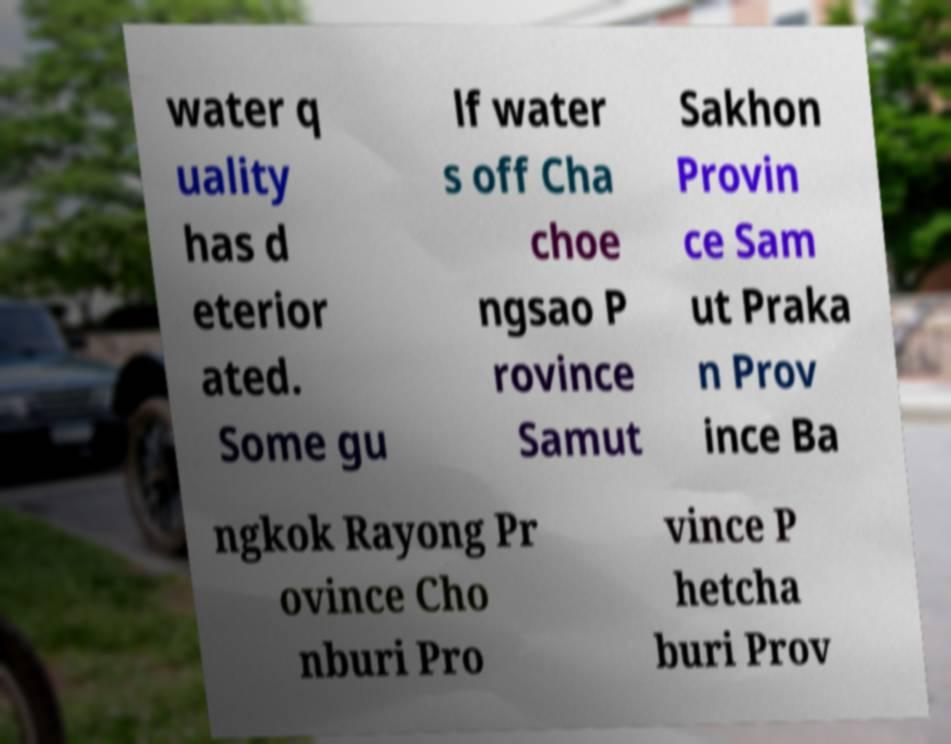Please read and relay the text visible in this image. What does it say? water q uality has d eterior ated. Some gu lf water s off Cha choe ngsao P rovince Samut Sakhon Provin ce Sam ut Praka n Prov ince Ba ngkok Rayong Pr ovince Cho nburi Pro vince P hetcha buri Prov 